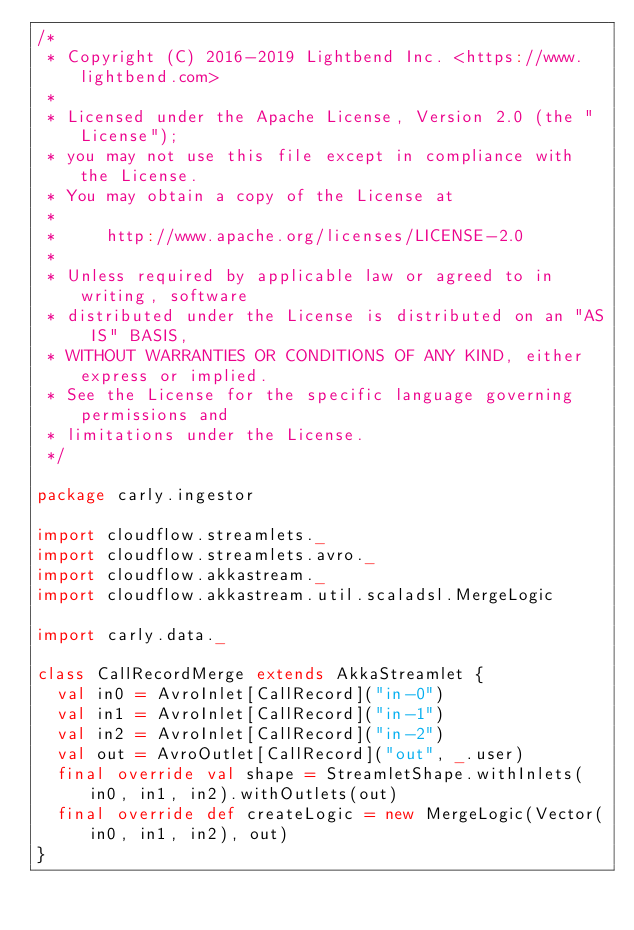<code> <loc_0><loc_0><loc_500><loc_500><_Scala_>/*
 * Copyright (C) 2016-2019 Lightbend Inc. <https://www.lightbend.com>
 *
 * Licensed under the Apache License, Version 2.0 (the "License");
 * you may not use this file except in compliance with the License.
 * You may obtain a copy of the License at
 *
 *     http://www.apache.org/licenses/LICENSE-2.0
 *
 * Unless required by applicable law or agreed to in writing, software
 * distributed under the License is distributed on an "AS IS" BASIS,
 * WITHOUT WARRANTIES OR CONDITIONS OF ANY KIND, either express or implied.
 * See the License for the specific language governing permissions and
 * limitations under the License.
 */

package carly.ingestor

import cloudflow.streamlets._
import cloudflow.streamlets.avro._
import cloudflow.akkastream._
import cloudflow.akkastream.util.scaladsl.MergeLogic

import carly.data._

class CallRecordMerge extends AkkaStreamlet {
  val in0 = AvroInlet[CallRecord]("in-0")
  val in1 = AvroInlet[CallRecord]("in-1")
  val in2 = AvroInlet[CallRecord]("in-2")
  val out = AvroOutlet[CallRecord]("out", _.user)
  final override val shape = StreamletShape.withInlets(in0, in1, in2).withOutlets(out)
  final override def createLogic = new MergeLogic(Vector(in0, in1, in2), out)
}
</code> 